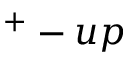Convert formula to latex. <formula><loc_0><loc_0><loc_500><loc_500>^ { + } - u p</formula> 